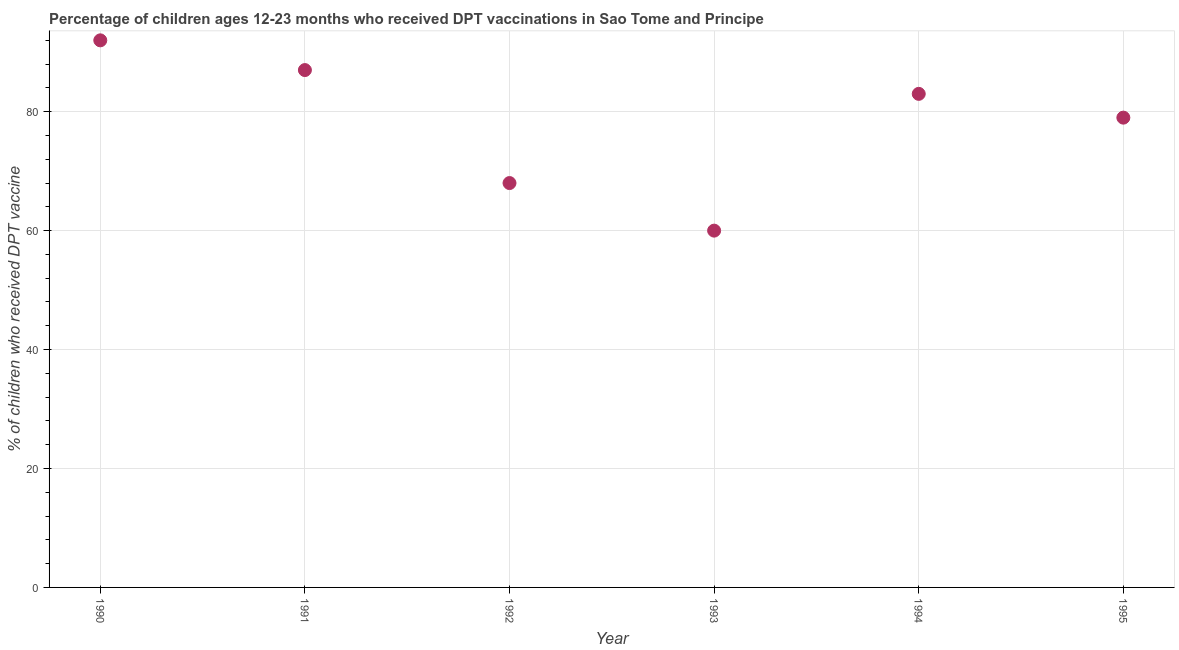What is the percentage of children who received dpt vaccine in 1990?
Keep it short and to the point. 92. Across all years, what is the maximum percentage of children who received dpt vaccine?
Ensure brevity in your answer.  92. Across all years, what is the minimum percentage of children who received dpt vaccine?
Make the answer very short. 60. In which year was the percentage of children who received dpt vaccine maximum?
Ensure brevity in your answer.  1990. In which year was the percentage of children who received dpt vaccine minimum?
Your answer should be very brief. 1993. What is the sum of the percentage of children who received dpt vaccine?
Provide a short and direct response. 469. What is the difference between the percentage of children who received dpt vaccine in 1990 and 1994?
Your answer should be very brief. 9. What is the average percentage of children who received dpt vaccine per year?
Your response must be concise. 78.17. What is the median percentage of children who received dpt vaccine?
Your answer should be very brief. 81. What is the ratio of the percentage of children who received dpt vaccine in 1990 to that in 1993?
Provide a short and direct response. 1.53. Is the percentage of children who received dpt vaccine in 1993 less than that in 1995?
Your answer should be compact. Yes. Is the difference between the percentage of children who received dpt vaccine in 1991 and 1993 greater than the difference between any two years?
Your answer should be very brief. No. Is the sum of the percentage of children who received dpt vaccine in 1991 and 1992 greater than the maximum percentage of children who received dpt vaccine across all years?
Offer a terse response. Yes. What is the difference between the highest and the lowest percentage of children who received dpt vaccine?
Provide a succinct answer. 32. Does the percentage of children who received dpt vaccine monotonically increase over the years?
Give a very brief answer. No. How many dotlines are there?
Make the answer very short. 1. How many years are there in the graph?
Provide a short and direct response. 6. What is the difference between two consecutive major ticks on the Y-axis?
Keep it short and to the point. 20. What is the title of the graph?
Offer a terse response. Percentage of children ages 12-23 months who received DPT vaccinations in Sao Tome and Principe. What is the label or title of the X-axis?
Your answer should be very brief. Year. What is the label or title of the Y-axis?
Provide a short and direct response. % of children who received DPT vaccine. What is the % of children who received DPT vaccine in 1990?
Provide a short and direct response. 92. What is the % of children who received DPT vaccine in 1992?
Give a very brief answer. 68. What is the % of children who received DPT vaccine in 1995?
Keep it short and to the point. 79. What is the difference between the % of children who received DPT vaccine in 1990 and 1991?
Give a very brief answer. 5. What is the difference between the % of children who received DPT vaccine in 1990 and 1993?
Give a very brief answer. 32. What is the difference between the % of children who received DPT vaccine in 1990 and 1994?
Your answer should be very brief. 9. What is the difference between the % of children who received DPT vaccine in 1991 and 1992?
Keep it short and to the point. 19. What is the difference between the % of children who received DPT vaccine in 1991 and 1993?
Give a very brief answer. 27. What is the difference between the % of children who received DPT vaccine in 1991 and 1994?
Your answer should be very brief. 4. What is the difference between the % of children who received DPT vaccine in 1991 and 1995?
Make the answer very short. 8. What is the difference between the % of children who received DPT vaccine in 1992 and 1993?
Make the answer very short. 8. What is the difference between the % of children who received DPT vaccine in 1992 and 1994?
Provide a succinct answer. -15. What is the difference between the % of children who received DPT vaccine in 1993 and 1995?
Your answer should be compact. -19. What is the ratio of the % of children who received DPT vaccine in 1990 to that in 1991?
Ensure brevity in your answer.  1.06. What is the ratio of the % of children who received DPT vaccine in 1990 to that in 1992?
Give a very brief answer. 1.35. What is the ratio of the % of children who received DPT vaccine in 1990 to that in 1993?
Your response must be concise. 1.53. What is the ratio of the % of children who received DPT vaccine in 1990 to that in 1994?
Your response must be concise. 1.11. What is the ratio of the % of children who received DPT vaccine in 1990 to that in 1995?
Your response must be concise. 1.17. What is the ratio of the % of children who received DPT vaccine in 1991 to that in 1992?
Give a very brief answer. 1.28. What is the ratio of the % of children who received DPT vaccine in 1991 to that in 1993?
Your response must be concise. 1.45. What is the ratio of the % of children who received DPT vaccine in 1991 to that in 1994?
Your response must be concise. 1.05. What is the ratio of the % of children who received DPT vaccine in 1991 to that in 1995?
Offer a terse response. 1.1. What is the ratio of the % of children who received DPT vaccine in 1992 to that in 1993?
Keep it short and to the point. 1.13. What is the ratio of the % of children who received DPT vaccine in 1992 to that in 1994?
Your response must be concise. 0.82. What is the ratio of the % of children who received DPT vaccine in 1992 to that in 1995?
Offer a terse response. 0.86. What is the ratio of the % of children who received DPT vaccine in 1993 to that in 1994?
Your answer should be compact. 0.72. What is the ratio of the % of children who received DPT vaccine in 1993 to that in 1995?
Your answer should be compact. 0.76. What is the ratio of the % of children who received DPT vaccine in 1994 to that in 1995?
Ensure brevity in your answer.  1.05. 